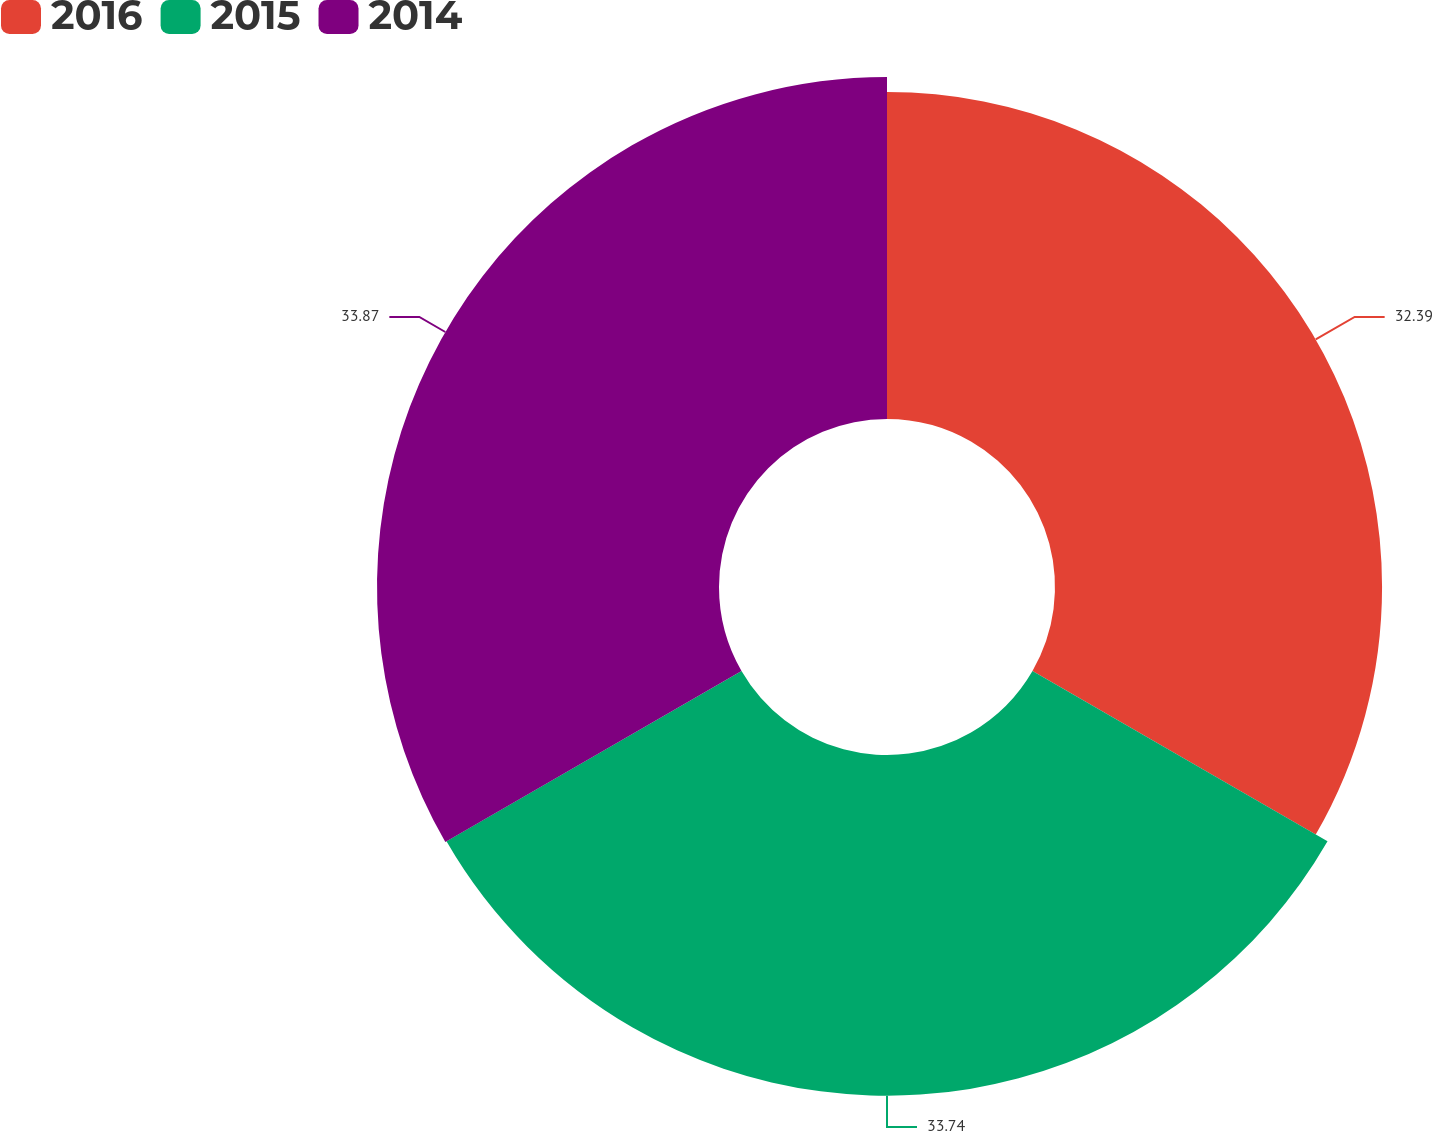Convert chart to OTSL. <chart><loc_0><loc_0><loc_500><loc_500><pie_chart><fcel>2016<fcel>2015<fcel>2014<nl><fcel>32.39%<fcel>33.74%<fcel>33.87%<nl></chart> 